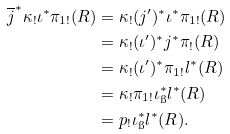<formula> <loc_0><loc_0><loc_500><loc_500>\overline { j } ^ { * } \kappa _ { ! } \iota ^ { * } \pi _ { 1 ! } ( R ) & = \kappa _ { ! } ( j ^ { \prime } ) ^ { * } \iota ^ { * } \pi _ { 1 ! } ( R ) \\ & = \kappa _ { ! } ( \iota ^ { \prime } ) ^ { * } j ^ { * } \pi _ { ! } ( R ) \\ & = \kappa _ { ! } ( \iota ^ { \prime } ) ^ { * } \pi _ { 1 ! } l ^ { * } ( R ) \\ & = \kappa _ { ! } \pi _ { 1 ! } \iota _ { \i } ^ { * } l ^ { * } ( R ) \\ & = p _ { ! } \iota _ { \i } ^ { * } l ^ { * } ( R ) .</formula> 